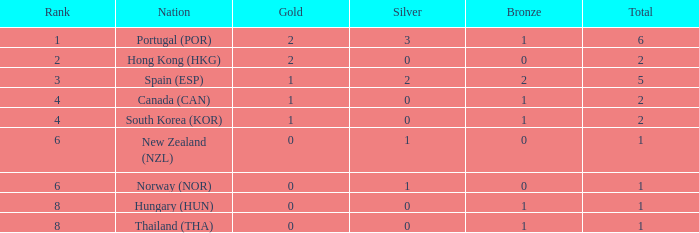Identify the rank number with no silver medals, 2 gold medals, and a total under 2. 0.0. 